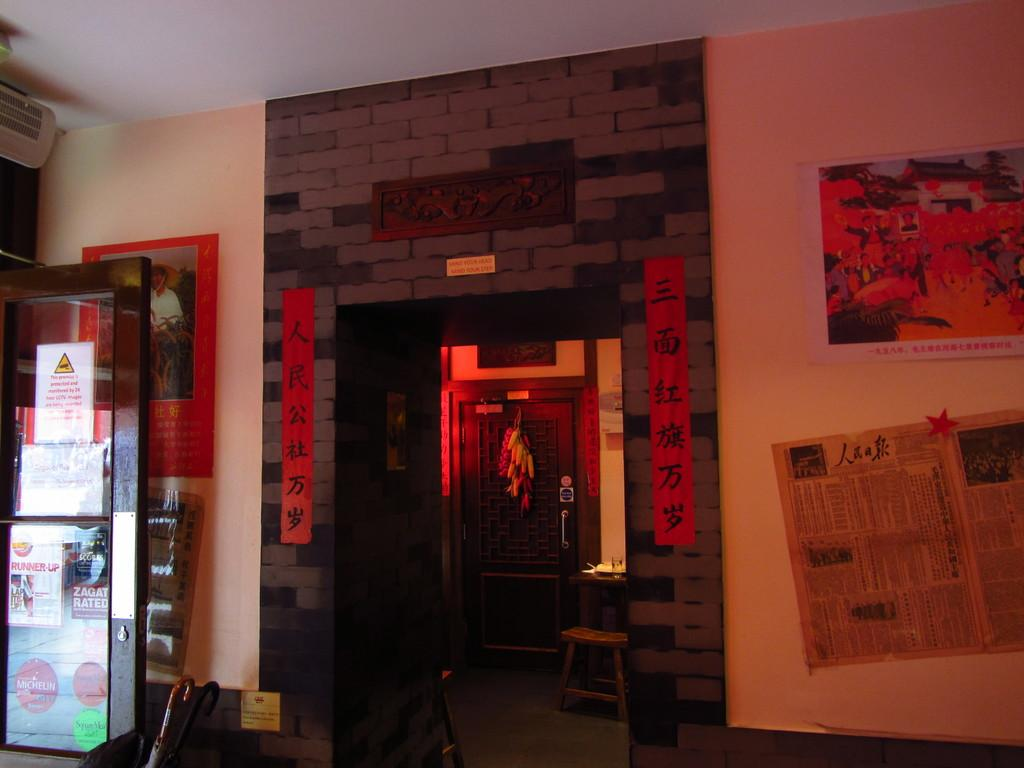What is hanging on the wall in the image? There are posters on the wall in the image. What is on the floor in the image? There are stools on the floor in the image. Can you describe any objects visible in the image? Yes, there are objects visible in the image. What can be seen in the background of the image? There is a roof in the background of the image. What type of belief is depicted on the posters in the image? There is no indication of any beliefs being depicted on the posters in the image. How many loaves of bread can be seen bursting in the image? There are no loaves of bread or any bursting objects present in the image. 